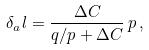Convert formula to latex. <formula><loc_0><loc_0><loc_500><loc_500>\delta _ { a } l = \frac { \Delta C } { q / p + \Delta C } \, p \, ,</formula> 